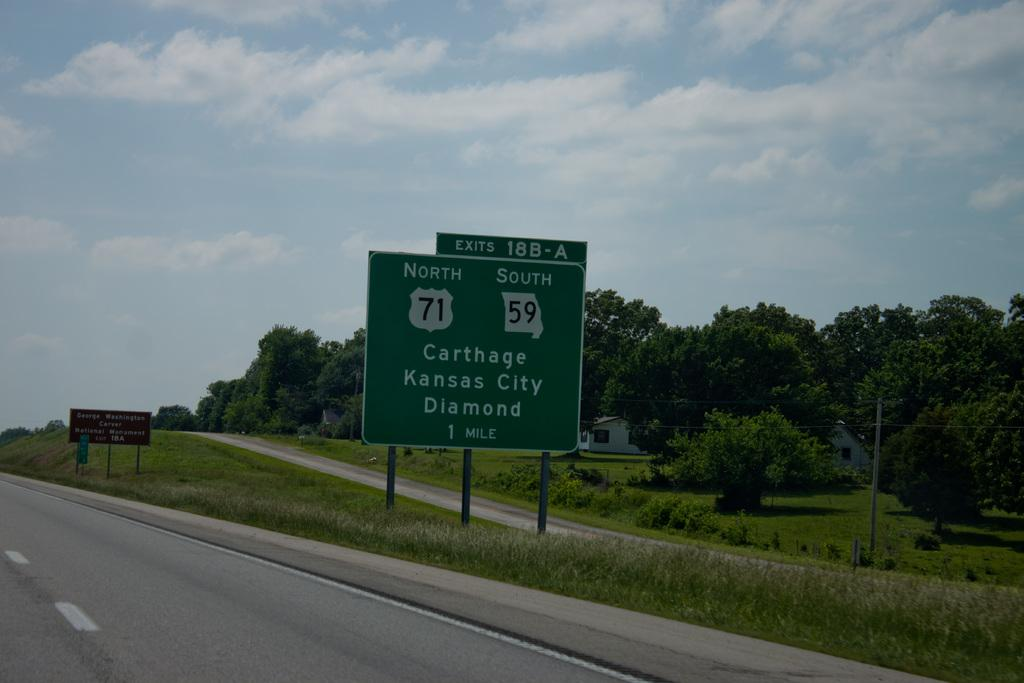<image>
Give a short and clear explanation of the subsequent image. the next exit 18B-A on the highway leads to north 71 or south 59 